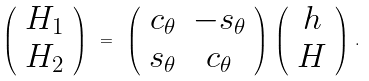<formula> <loc_0><loc_0><loc_500><loc_500>\left ( \begin{array} { c } H _ { 1 } \\ H _ { 2 } \end{array} \right ) \ = \ \left ( \begin{array} { c c } c _ { \theta } & - s _ { \theta } \\ s _ { \theta } & c _ { \theta } \end{array} \right ) \, \left ( \begin{array} { c } h \\ H \end{array} \right ) \, .</formula> 